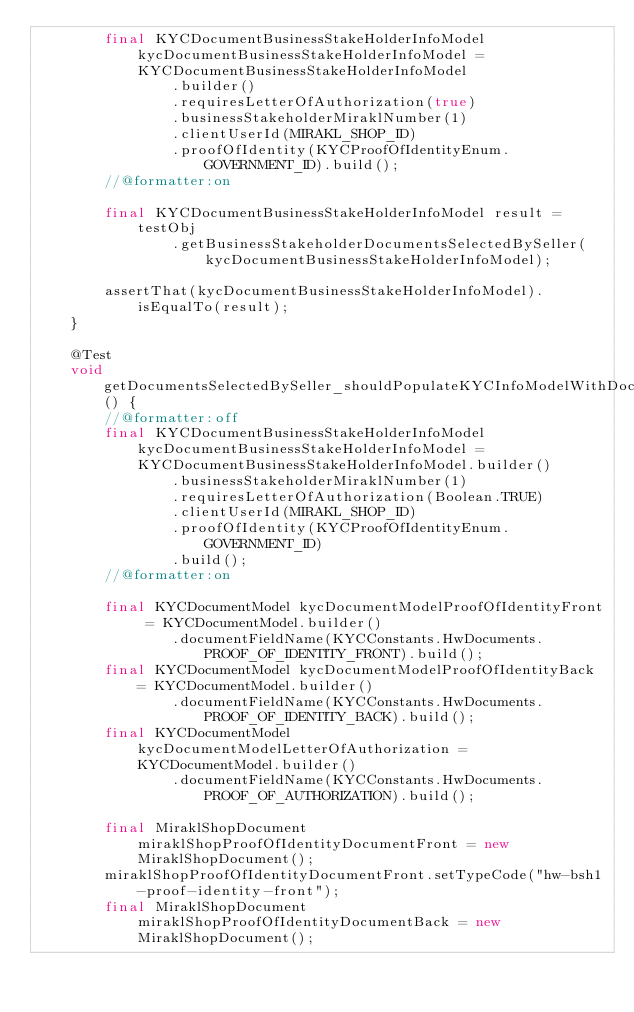Convert code to text. <code><loc_0><loc_0><loc_500><loc_500><_Java_>		final KYCDocumentBusinessStakeHolderInfoModel kycDocumentBusinessStakeHolderInfoModel = KYCDocumentBusinessStakeHolderInfoModel
				.builder()
				.requiresLetterOfAuthorization(true)
				.businessStakeholderMiraklNumber(1)
				.clientUserId(MIRAKL_SHOP_ID)
				.proofOfIdentity(KYCProofOfIdentityEnum.GOVERNMENT_ID).build();
		//@formatter:on

		final KYCDocumentBusinessStakeHolderInfoModel result = testObj
				.getBusinessStakeholderDocumentsSelectedBySeller(kycDocumentBusinessStakeHolderInfoModel);

		assertThat(kycDocumentBusinessStakeHolderInfoModel).isEqualTo(result);
	}

	@Test
	void getDocumentsSelectedBySeller_shouldPopulateKYCInfoModelWithDocumentInformationAndReturnDocumentsReturnedByStrategies_whenLetterOfAuthorationIsRequiredAndLetterOfAuthorizationDocumentIsFilled() {
		//@formatter:off
		final KYCDocumentBusinessStakeHolderInfoModel kycDocumentBusinessStakeHolderInfoModel = KYCDocumentBusinessStakeHolderInfoModel.builder()
				.businessStakeholderMiraklNumber(1)
				.requiresLetterOfAuthorization(Boolean.TRUE)
				.clientUserId(MIRAKL_SHOP_ID)
				.proofOfIdentity(KYCProofOfIdentityEnum.GOVERNMENT_ID)
				.build();
		//@formatter:on

		final KYCDocumentModel kycDocumentModelProofOfIdentityFront = KYCDocumentModel.builder()
				.documentFieldName(KYCConstants.HwDocuments.PROOF_OF_IDENTITY_FRONT).build();
		final KYCDocumentModel kycDocumentModelProofOfIdentityBack = KYCDocumentModel.builder()
				.documentFieldName(KYCConstants.HwDocuments.PROOF_OF_IDENTITY_BACK).build();
		final KYCDocumentModel kycDocumentModelLetterOfAuthorization = KYCDocumentModel.builder()
				.documentFieldName(KYCConstants.HwDocuments.PROOF_OF_AUTHORIZATION).build();

		final MiraklShopDocument miraklShopProofOfIdentityDocumentFront = new MiraklShopDocument();
		miraklShopProofOfIdentityDocumentFront.setTypeCode("hw-bsh1-proof-identity-front");
		final MiraklShopDocument miraklShopProofOfIdentityDocumentBack = new MiraklShopDocument();</code> 